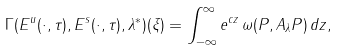Convert formula to latex. <formula><loc_0><loc_0><loc_500><loc_500>\Gamma ( E ^ { u } ( \cdot , \tau ) , E ^ { s } ( \cdot , \tau ) , \lambda ^ { * } ) ( \xi ) = \int _ { - \infty } ^ { \infty } e ^ { c z } \, \omega ( P , A _ { \lambda } P ) \, d z ,</formula> 